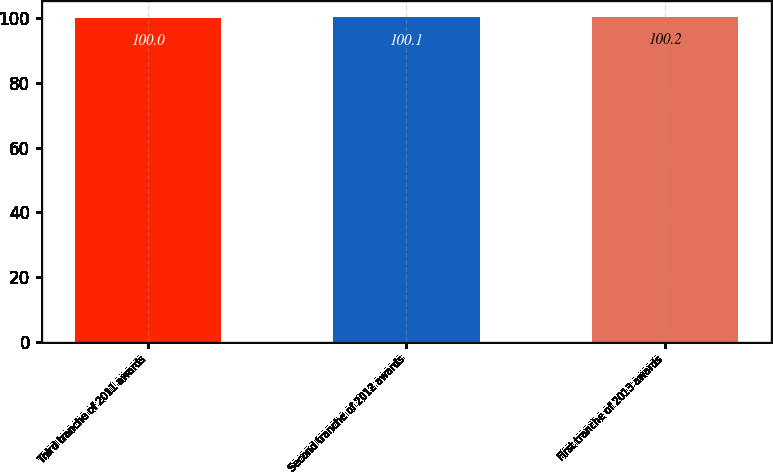<chart> <loc_0><loc_0><loc_500><loc_500><bar_chart><fcel>Third tranche of 2011 awards<fcel>Second tranche of 2012 awards<fcel>First tranche of 2013 awards<nl><fcel>100<fcel>100.1<fcel>100.2<nl></chart> 